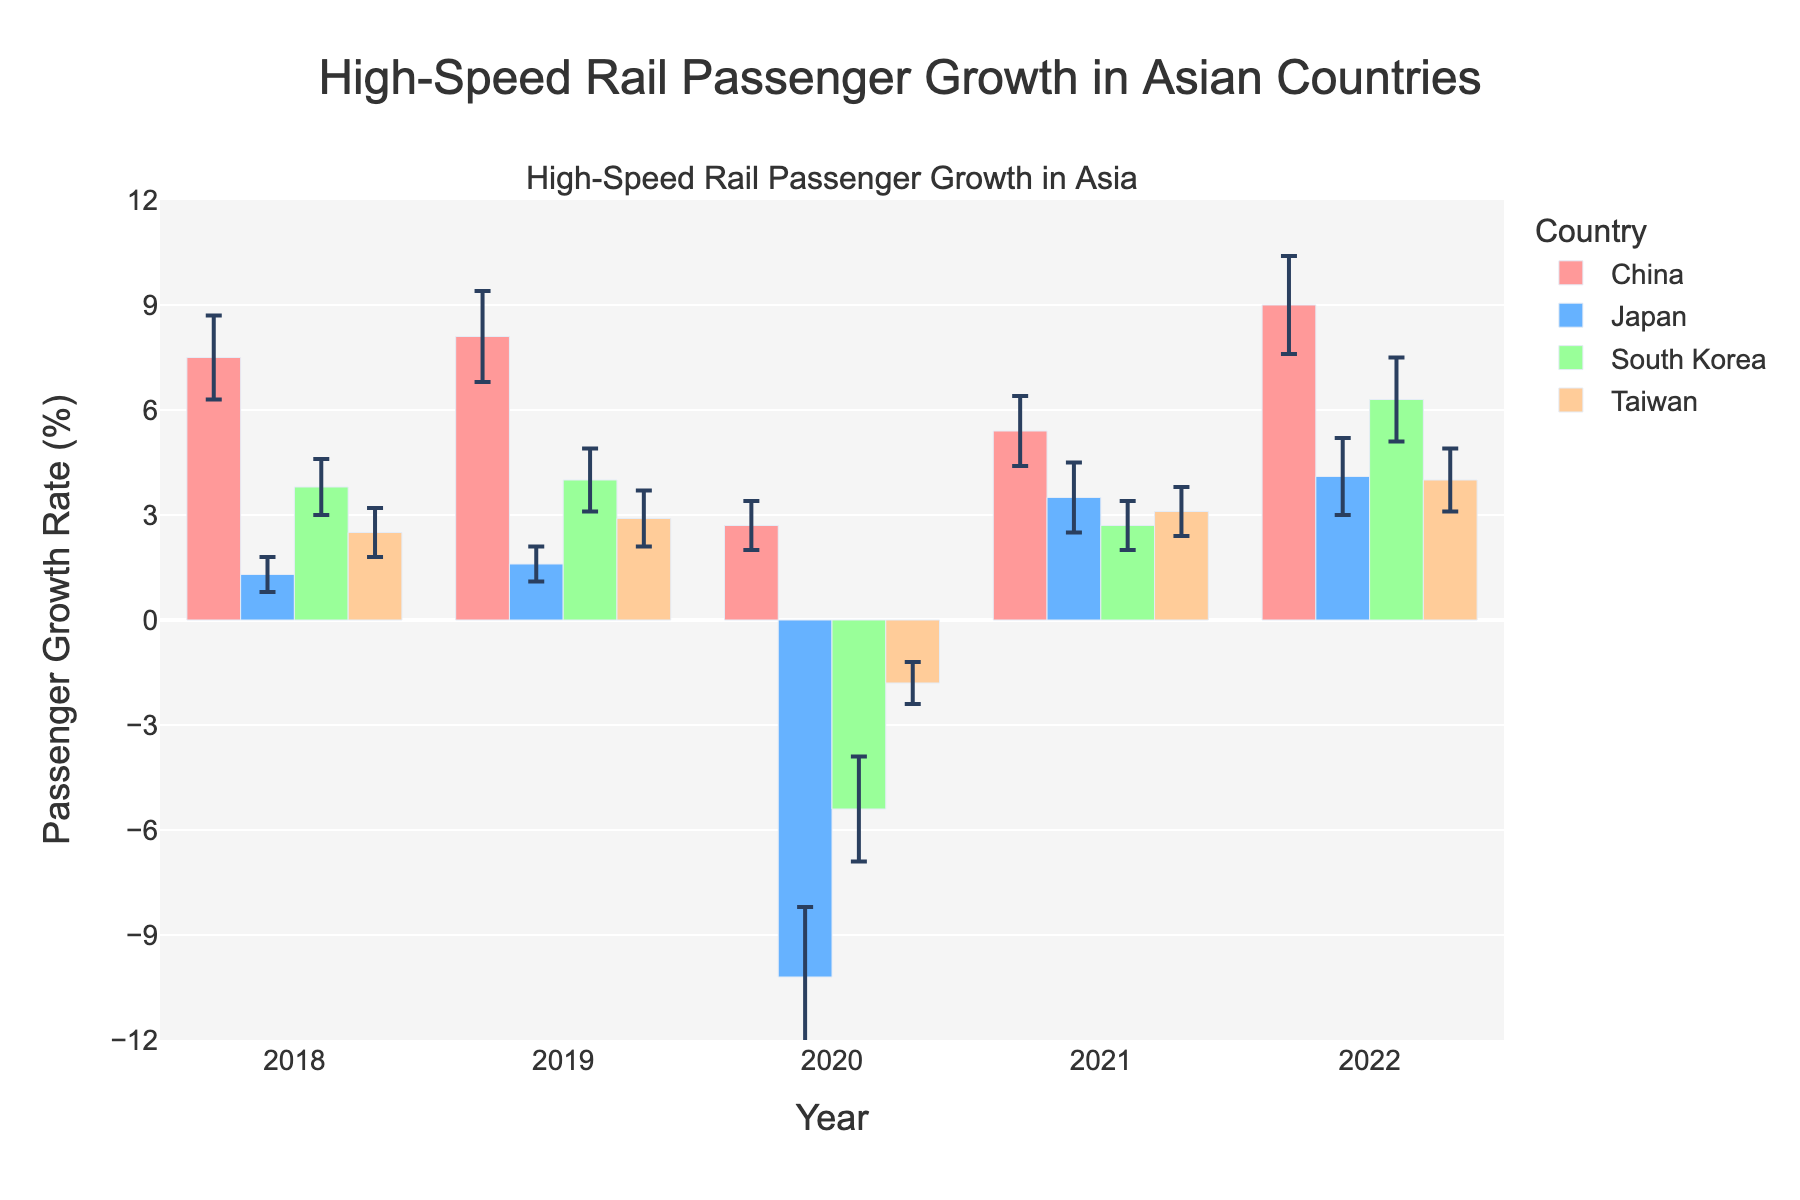What is the title of the figure? The title is usually found at the top of the plot and often summarizes what the chart is about.
Answer: High-Speed Rail Passenger Growth in Asian Countries What is the passenger growth rate for Japan in 2020? Look for the bar corresponding to Japan in 2020 and read the height of the bar.
Answer: -10.2% Which country had the highest passenger growth rate in 2022? Compare the heights of the bars across all countries for the year 2022 and identify the tallest one.
Answer: China What is the error margin for South Korea's passenger growth rate in 2019? Locate the 2019 bar for South Korea and look at the upper and lower bounds of the error bars.
Answer: 0.9% Which country experienced a negative passenger growth rate in 2020? Identify the bars in 2020 with their heights below the zero line and note the corresponding countries.
Answer: Japan, South Korea, Taiwan Between 2018 and 2022, which year had the highest passenger growth rate for China? Examine all the bars for China and identify the tallest one within the specified years.
Answer: 2022 What is the average growth rate of high-speed rail passengers in Japan between 2018 and 2022? Add the growth rates for Japan from 2018 to 2022 and divide by the number of years (5). (1.3 + 1.6 - 10.2 + 3.5 + 4.1) / 5 = (1.3 + 1.6 - 10.2 + 3.5 + 4.1) / 5 = 0.06%
Answer: 0.06% Which country showed the most consistent growth rate (smallest variation) based on the error margins given? Compare the error margins for each country across all years and identify the country with the smallest range.
Answer: Taiwan What is the difference in passenger growth rate between China and South Korea in 2020? Read the values for China and South Korea in 2020 and subtract South Korea's rate from China's rate. 2.7 - (-5.4) = 2.7 + 5.4 = 8.1%
Answer: 8.1% How does Japan's growth rate in 2021 compare to its growth rate in 2018? Subtract Japan's growth rate in 2018 from its growth rate in 2021 to find the difference. 3.5 - 1.3 = 2.2%
Answer: 2.2% 